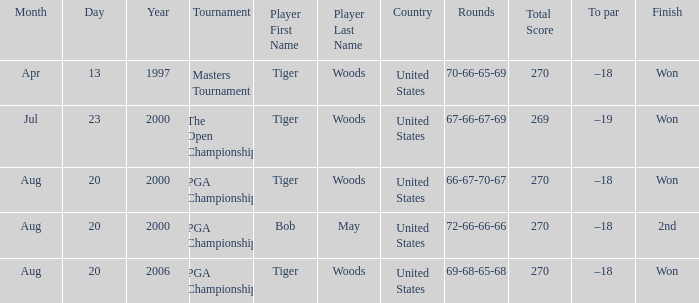What days were the rounds of 66-67-70-67 recorded? Aug 20, 2000. 